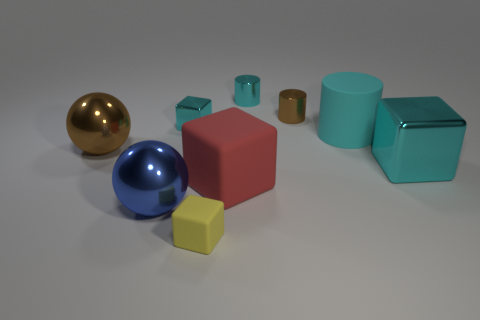Is the number of rubber cubes in front of the blue shiny thing less than the number of big shiny things on the left side of the big cyan rubber cylinder?
Your answer should be compact. Yes. What number of objects are either cylinders right of the brown metallic cylinder or large cyan cylinders?
Ensure brevity in your answer.  1. Does the brown cylinder have the same size as the cyan shiny thing that is left of the large red rubber cube?
Your response must be concise. Yes. What is the size of the cyan metal thing that is the same shape as the tiny brown object?
Make the answer very short. Small. How many large metallic spheres are behind the brown object behind the small block that is behind the big cyan cylinder?
Keep it short and to the point. 0. How many balls are either large brown objects or tiny things?
Provide a short and direct response. 1. The big metallic sphere behind the big cube that is right of the tiny cylinder behind the brown cylinder is what color?
Your response must be concise. Brown. What number of other objects are the same size as the blue shiny sphere?
Make the answer very short. 4. There is another big shiny object that is the same shape as the blue metal thing; what color is it?
Keep it short and to the point. Brown. What is the color of the large cube that is the same material as the tiny cyan cylinder?
Offer a terse response. Cyan. 